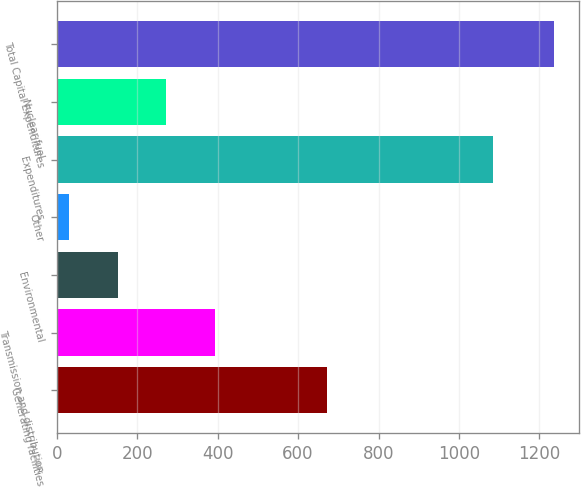<chart> <loc_0><loc_0><loc_500><loc_500><bar_chart><fcel>Generating facilities<fcel>Transmission and distribution<fcel>Environmental<fcel>Other<fcel>Expenditures<fcel>Nuclear fuel<fcel>Total Capital Expenditures<nl><fcel>671<fcel>392.5<fcel>151.5<fcel>31<fcel>1085<fcel>272<fcel>1236<nl></chart> 